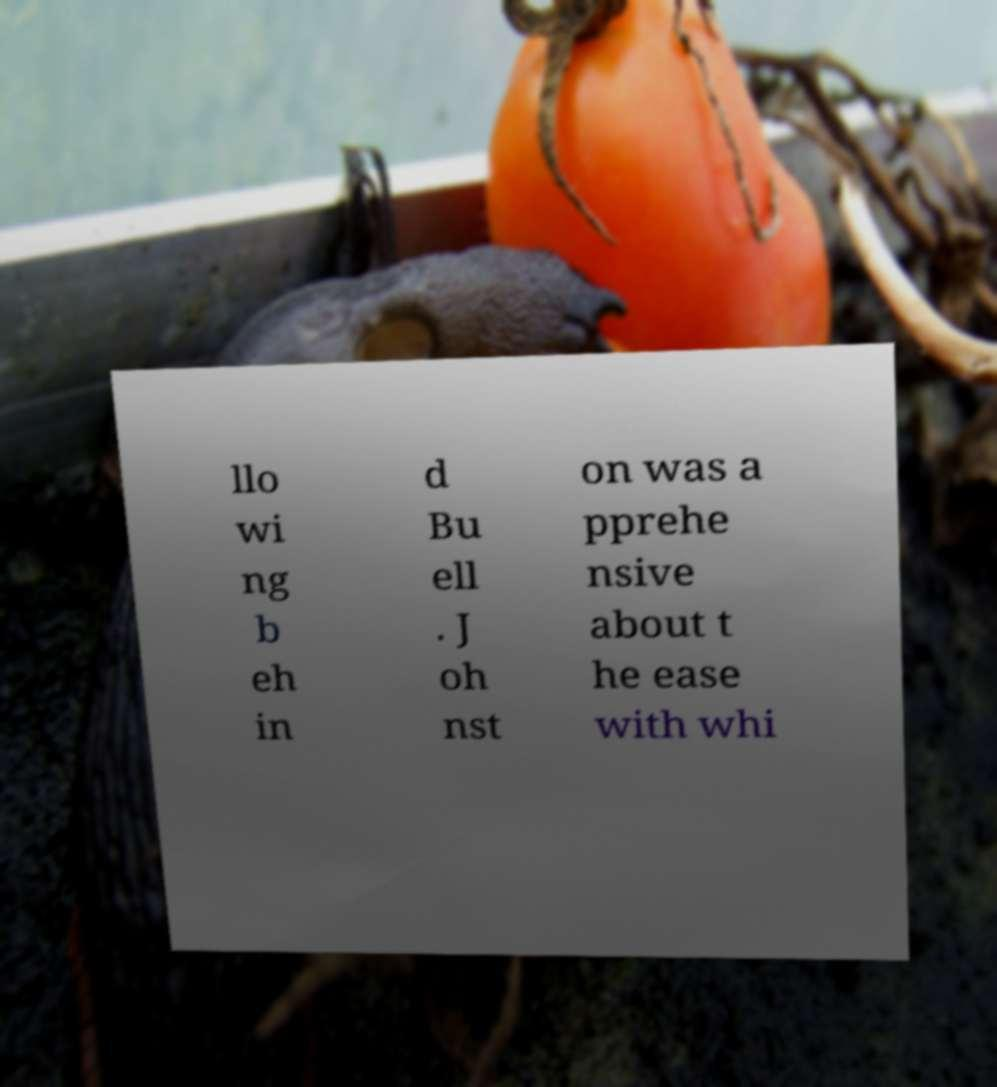For documentation purposes, I need the text within this image transcribed. Could you provide that? llo wi ng b eh in d Bu ell . J oh nst on was a pprehe nsive about t he ease with whi 